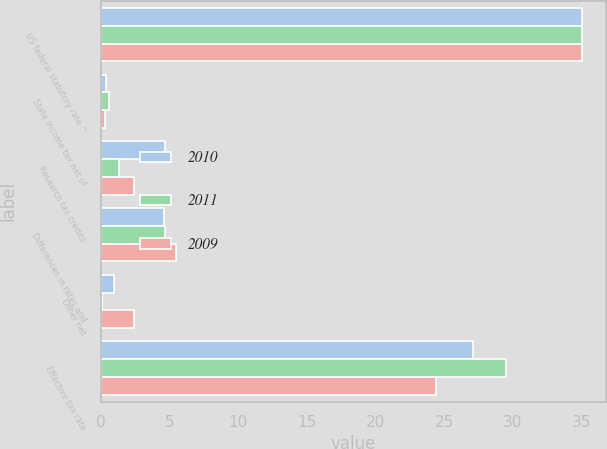Convert chart to OTSL. <chart><loc_0><loc_0><loc_500><loc_500><stacked_bar_chart><ecel><fcel>US federal statutory rate ^<fcel>State income tax net of<fcel>Research tax credits<fcel>Differences in rates and<fcel>Other net<fcel>Effective tax rate<nl><fcel>2010<fcel>35<fcel>0.4<fcel>4.7<fcel>4.6<fcel>1<fcel>27.1<nl><fcel>2011<fcel>35<fcel>0.6<fcel>1.3<fcel>4.7<fcel>0.1<fcel>29.5<nl><fcel>2009<fcel>35<fcel>0.3<fcel>2.4<fcel>5.5<fcel>2.4<fcel>24.4<nl></chart> 